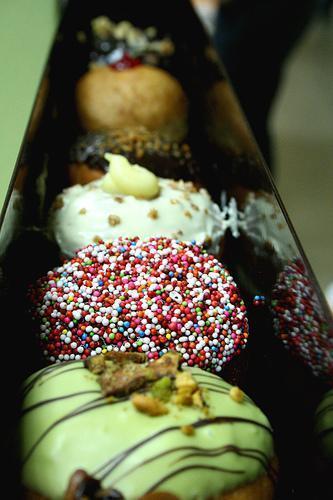How many donuts are pictured?
Give a very brief answer. 6. How many donuts are there?
Give a very brief answer. 7. How many cakes are there?
Give a very brief answer. 2. How many people in this image are wearing a white jacket?
Give a very brief answer. 0. 